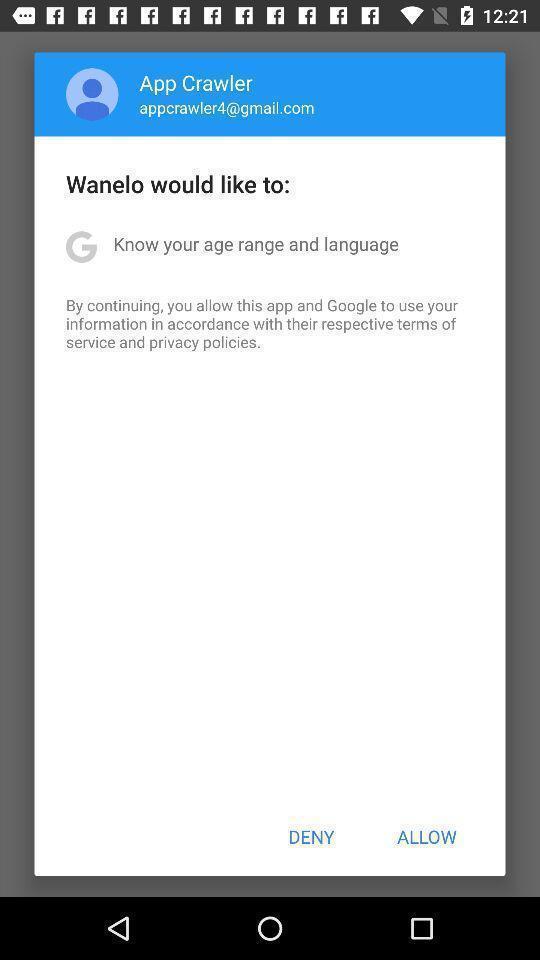Describe the content in this image. Pop-up displaying to allow an application. 